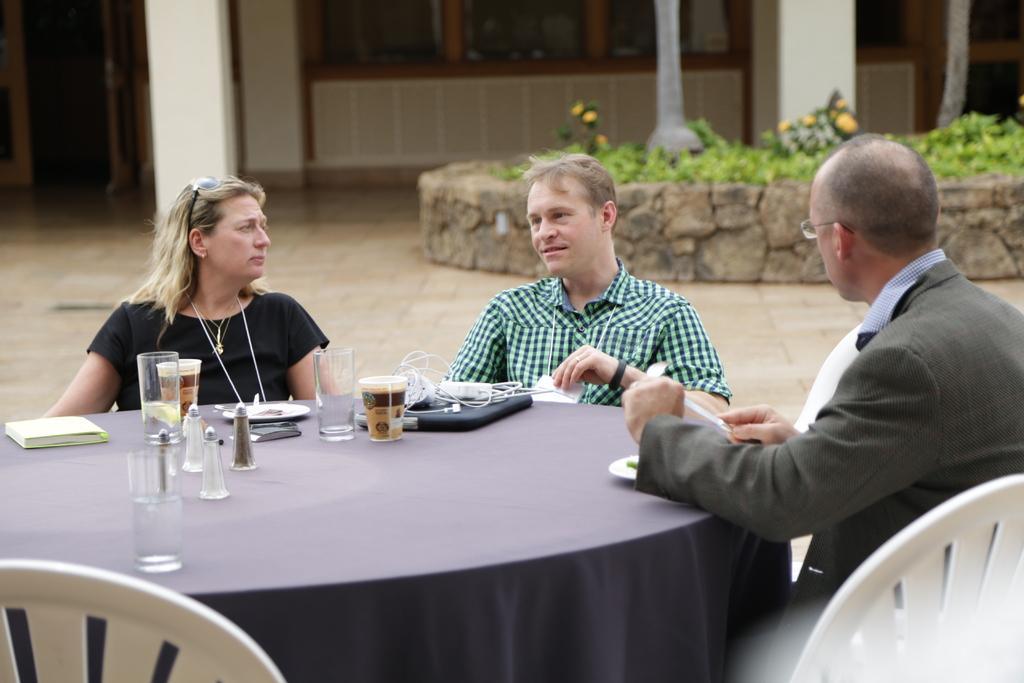Describe this image in one or two sentences. In this picture we can see two men and one woman sitting on chair where in middle person is talking and in front of them on table we have glasses, box, wires, bookplate and in background we can see plants, wall, pillar, windows, door. 